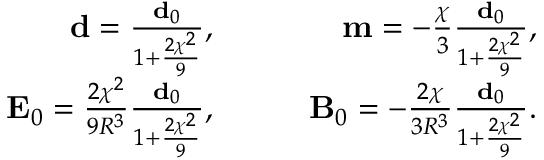Convert formula to latex. <formula><loc_0><loc_0><loc_500><loc_500>\begin{array} { r l r } { d = \frac { d _ { 0 } } { 1 + \frac { 2 \chi ^ { 2 } } { 9 } } , } & { \quad } & { m = - \frac { \chi } { 3 } \frac { d _ { 0 } } { 1 + \frac { 2 \chi ^ { 2 } } { 9 } } , } \\ { E _ { 0 } = \frac { 2 \chi ^ { 2 } } { 9 R ^ { 3 } } \frac { d _ { 0 } } { 1 + \frac { 2 \chi ^ { 2 } } { 9 } } , } & { \quad } & { B _ { 0 } = - \frac { 2 \chi } { 3 R ^ { 3 } } \frac { d _ { 0 } } { 1 + \frac { 2 \chi ^ { 2 } } { 9 } } . } \end{array}</formula> 